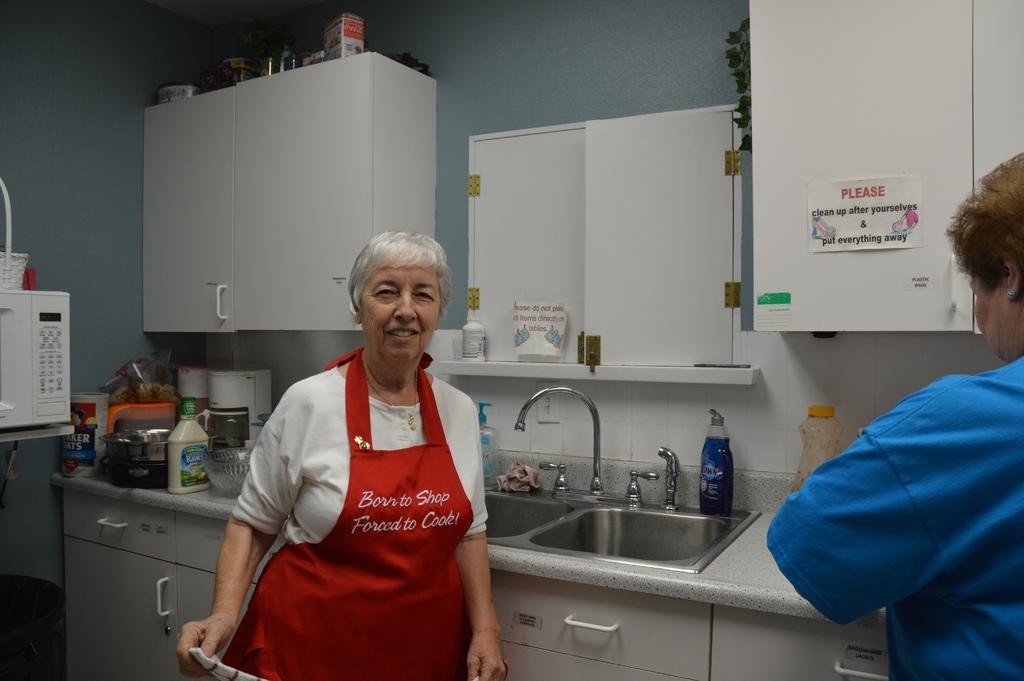<image>
Write a terse but informative summary of the picture. a lady is standing in a kitchen with a sign on the cabinet asking people to clean up after theirselves 